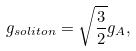<formula> <loc_0><loc_0><loc_500><loc_500>g _ { s o l i t o n } = \sqrt { \frac { 3 } { 2 } } g _ { A } ,</formula> 